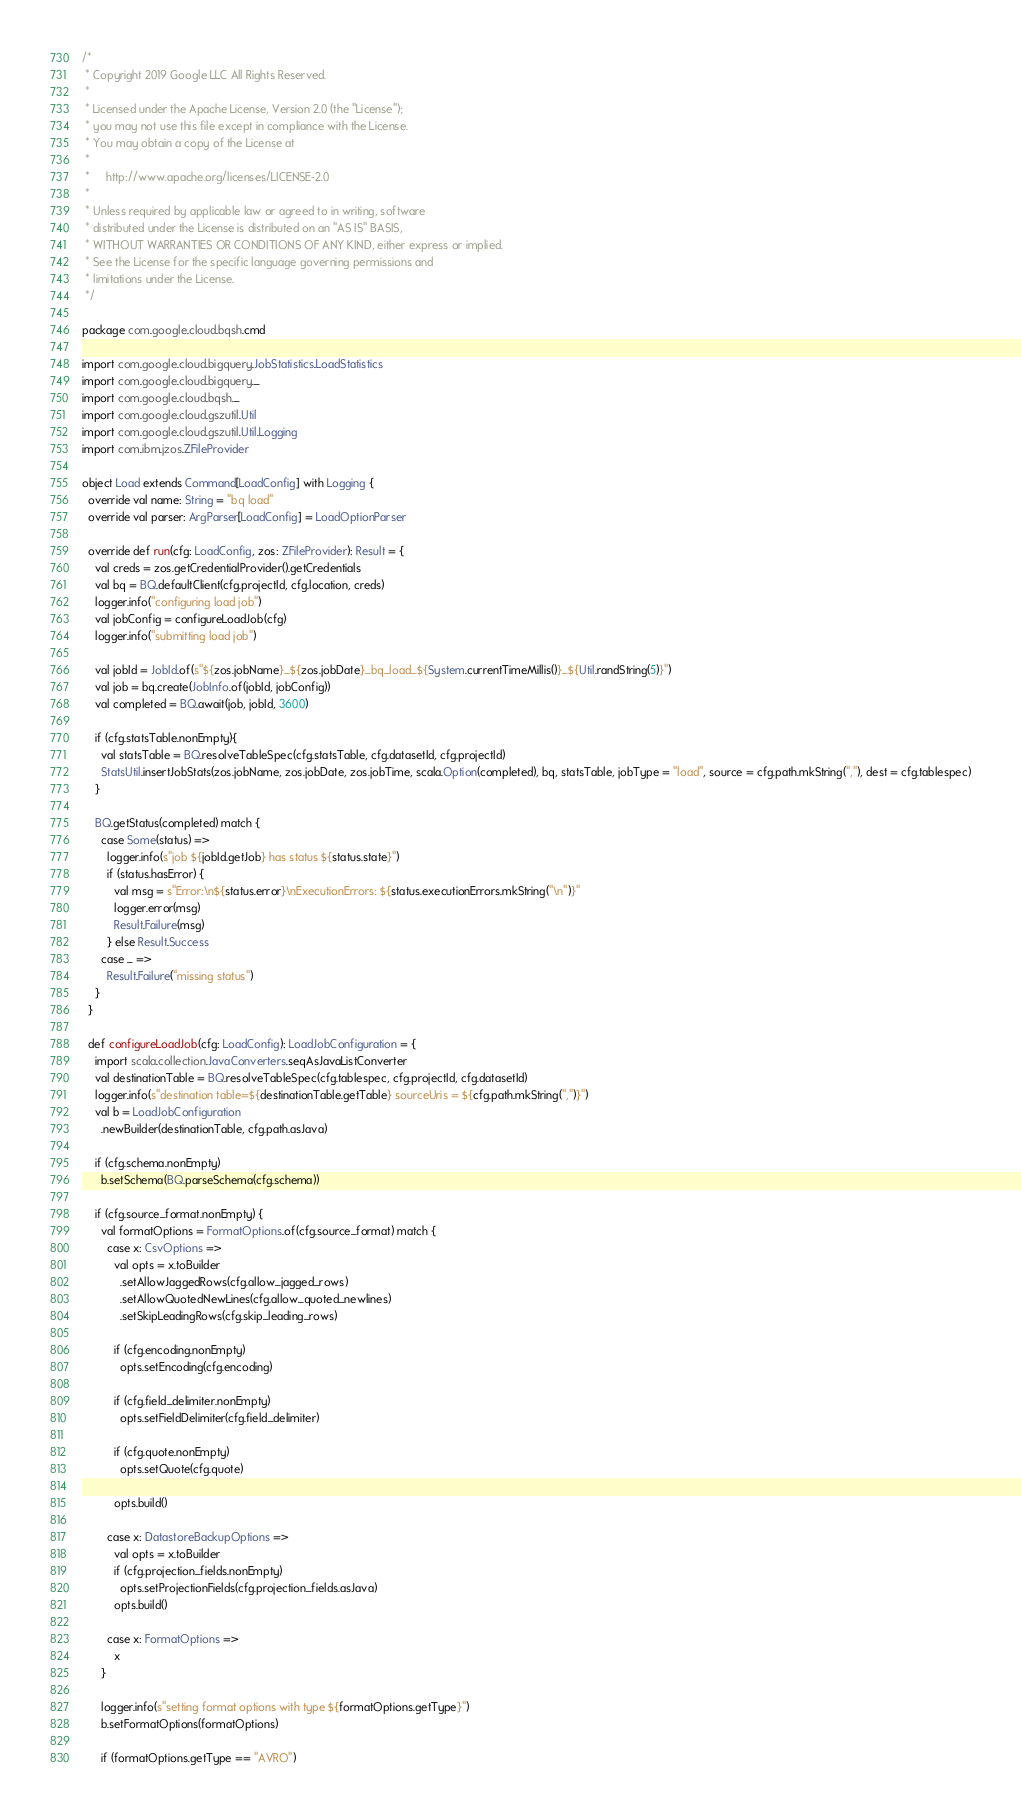<code> <loc_0><loc_0><loc_500><loc_500><_Scala_>/*
 * Copyright 2019 Google LLC All Rights Reserved.
 *
 * Licensed under the Apache License, Version 2.0 (the "License");
 * you may not use this file except in compliance with the License.
 * You may obtain a copy of the License at
 *
 *     http://www.apache.org/licenses/LICENSE-2.0
 *
 * Unless required by applicable law or agreed to in writing, software
 * distributed under the License is distributed on an "AS IS" BASIS,
 * WITHOUT WARRANTIES OR CONDITIONS OF ANY KIND, either express or implied.
 * See the License for the specific language governing permissions and
 * limitations under the License.
 */

package com.google.cloud.bqsh.cmd

import com.google.cloud.bigquery.JobStatistics.LoadStatistics
import com.google.cloud.bigquery._
import com.google.cloud.bqsh._
import com.google.cloud.gszutil.Util
import com.google.cloud.gszutil.Util.Logging
import com.ibm.jzos.ZFileProvider

object Load extends Command[LoadConfig] with Logging {
  override val name: String = "bq load"
  override val parser: ArgParser[LoadConfig] = LoadOptionParser

  override def run(cfg: LoadConfig, zos: ZFileProvider): Result = {
    val creds = zos.getCredentialProvider().getCredentials
    val bq = BQ.defaultClient(cfg.projectId, cfg.location, creds)
    logger.info("configuring load job")
    val jobConfig = configureLoadJob(cfg)
    logger.info("submitting load job")

    val jobId = JobId.of(s"${zos.jobName}_${zos.jobDate}_bq_load_${System.currentTimeMillis()}_${Util.randString(5)}")
    val job = bq.create(JobInfo.of(jobId, jobConfig))
    val completed = BQ.await(job, jobId, 3600)

    if (cfg.statsTable.nonEmpty){
      val statsTable = BQ.resolveTableSpec(cfg.statsTable, cfg.datasetId, cfg.projectId)
      StatsUtil.insertJobStats(zos.jobName, zos.jobDate, zos.jobTime, scala.Option(completed), bq, statsTable, jobType = "load", source = cfg.path.mkString(","), dest = cfg.tablespec)
    }

    BQ.getStatus(completed) match {
      case Some(status) =>
        logger.info(s"job ${jobId.getJob} has status ${status.state}")
        if (status.hasError) {
          val msg = s"Error:\n${status.error}\nExecutionErrors: ${status.executionErrors.mkString("\n")}"
          logger.error(msg)
          Result.Failure(msg)
        } else Result.Success
      case _ =>
        Result.Failure("missing status")
    }
  }

  def configureLoadJob(cfg: LoadConfig): LoadJobConfiguration = {
    import scala.collection.JavaConverters.seqAsJavaListConverter
    val destinationTable = BQ.resolveTableSpec(cfg.tablespec, cfg.projectId, cfg.datasetId)
    logger.info(s"destination table=${destinationTable.getTable} sourceUris = ${cfg.path.mkString(",")}")
    val b = LoadJobConfiguration
      .newBuilder(destinationTable, cfg.path.asJava)

    if (cfg.schema.nonEmpty)
      b.setSchema(BQ.parseSchema(cfg.schema))

    if (cfg.source_format.nonEmpty) {
      val formatOptions = FormatOptions.of(cfg.source_format) match {
        case x: CsvOptions =>
          val opts = x.toBuilder
            .setAllowJaggedRows(cfg.allow_jagged_rows)
            .setAllowQuotedNewLines(cfg.allow_quoted_newlines)
            .setSkipLeadingRows(cfg.skip_leading_rows)

          if (cfg.encoding.nonEmpty)
            opts.setEncoding(cfg.encoding)

          if (cfg.field_delimiter.nonEmpty)
            opts.setFieldDelimiter(cfg.field_delimiter)

          if (cfg.quote.nonEmpty)
            opts.setQuote(cfg.quote)

          opts.build()

        case x: DatastoreBackupOptions =>
          val opts = x.toBuilder
          if (cfg.projection_fields.nonEmpty)
            opts.setProjectionFields(cfg.projection_fields.asJava)
          opts.build()

        case x: FormatOptions =>
          x
      }

      logger.info(s"setting format options with type ${formatOptions.getType}")
      b.setFormatOptions(formatOptions)

      if (formatOptions.getType == "AVRO")</code> 